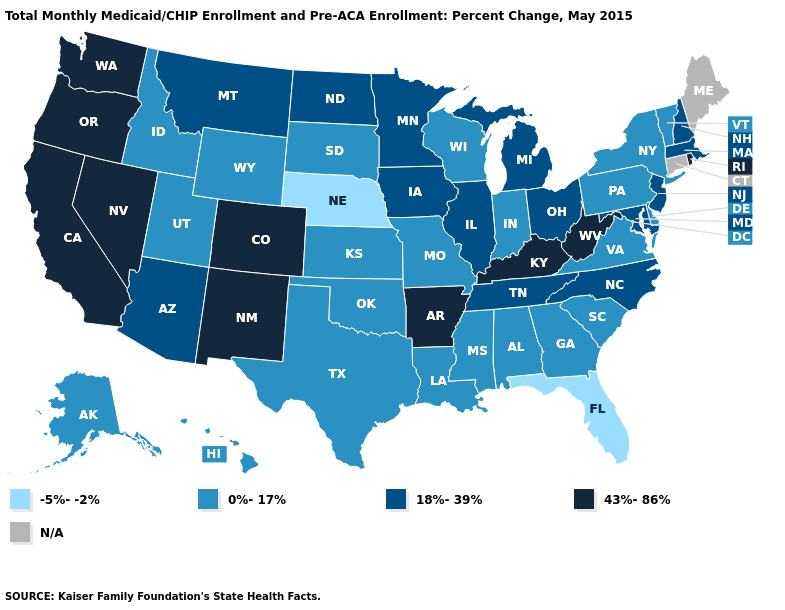What is the value of New Mexico?
Concise answer only. 43%-86%. Does Alabama have the lowest value in the South?
Answer briefly. No. Name the states that have a value in the range 43%-86%?
Write a very short answer. Arkansas, California, Colorado, Kentucky, Nevada, New Mexico, Oregon, Rhode Island, Washington, West Virginia. Which states have the lowest value in the Northeast?
Answer briefly. New York, Pennsylvania, Vermont. Name the states that have a value in the range 43%-86%?
Short answer required. Arkansas, California, Colorado, Kentucky, Nevada, New Mexico, Oregon, Rhode Island, Washington, West Virginia. How many symbols are there in the legend?
Concise answer only. 5. What is the value of North Dakota?
Quick response, please. 18%-39%. Name the states that have a value in the range N/A?
Be succinct. Connecticut, Maine. Among the states that border Nebraska , does Kansas have the highest value?
Quick response, please. No. What is the value of Hawaii?
Be succinct. 0%-17%. Does Minnesota have the highest value in the MidWest?
Be succinct. Yes. 